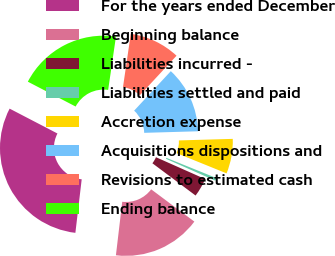<chart> <loc_0><loc_0><loc_500><loc_500><pie_chart><fcel>For the years ended December<fcel>Beginning balance<fcel>Liabilities incurred -<fcel>Liabilities settled and paid<fcel>Accretion expense<fcel>Acquisitions dispositions and<fcel>Revisions to estimated cash<fcel>Ending balance<nl><fcel>30.76%<fcel>16.66%<fcel>3.56%<fcel>0.53%<fcel>6.58%<fcel>12.63%<fcel>9.6%<fcel>19.68%<nl></chart> 